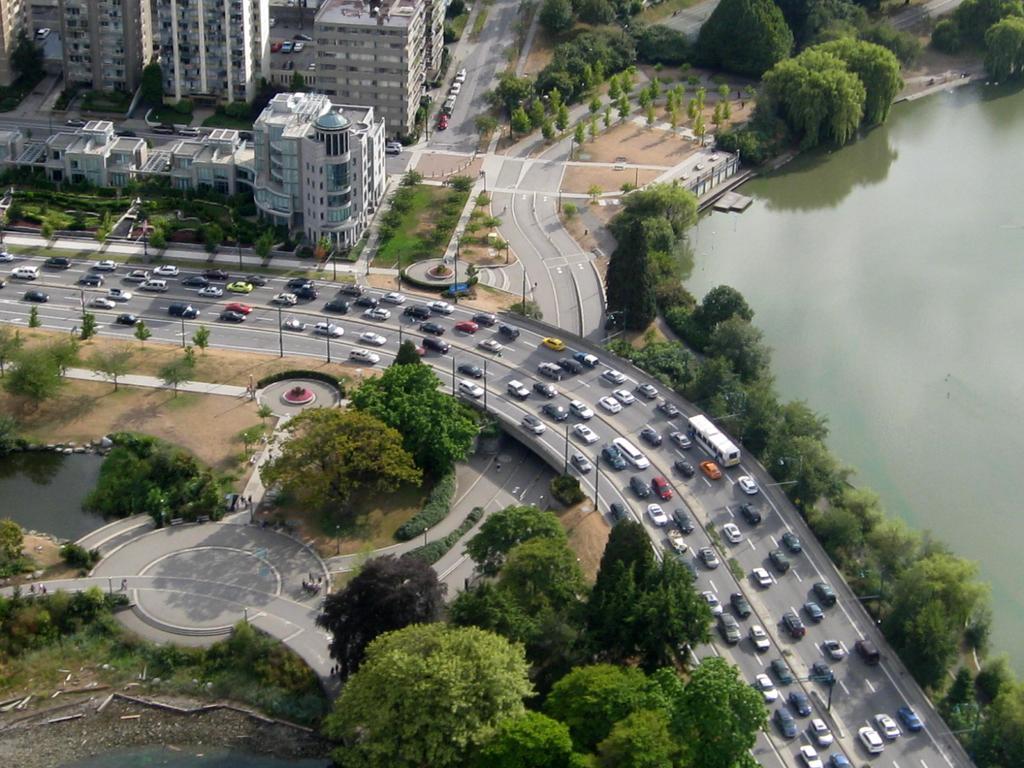In one or two sentences, can you explain what this image depicts? This is an aerial view of an image where we can see trees, vehicles moving on the road, I can see tower buildings and the water. 